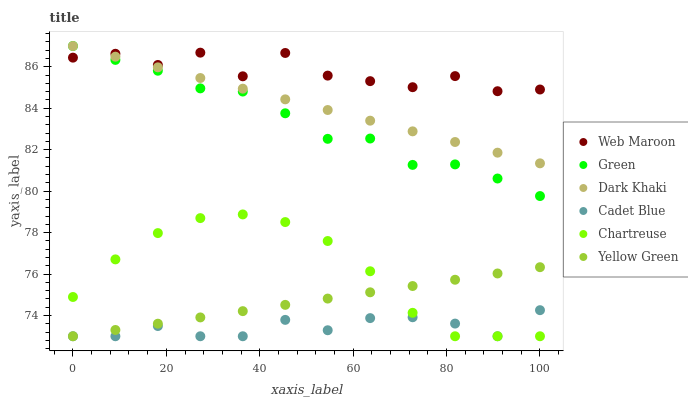Does Cadet Blue have the minimum area under the curve?
Answer yes or no. Yes. Does Web Maroon have the maximum area under the curve?
Answer yes or no. Yes. Does Yellow Green have the minimum area under the curve?
Answer yes or no. No. Does Yellow Green have the maximum area under the curve?
Answer yes or no. No. Is Yellow Green the smoothest?
Answer yes or no. Yes. Is Web Maroon the roughest?
Answer yes or no. Yes. Is Web Maroon the smoothest?
Answer yes or no. No. Is Yellow Green the roughest?
Answer yes or no. No. Does Cadet Blue have the lowest value?
Answer yes or no. Yes. Does Web Maroon have the lowest value?
Answer yes or no. No. Does Green have the highest value?
Answer yes or no. Yes. Does Yellow Green have the highest value?
Answer yes or no. No. Is Yellow Green less than Dark Khaki?
Answer yes or no. Yes. Is Green greater than Yellow Green?
Answer yes or no. Yes. Does Chartreuse intersect Cadet Blue?
Answer yes or no. Yes. Is Chartreuse less than Cadet Blue?
Answer yes or no. No. Is Chartreuse greater than Cadet Blue?
Answer yes or no. No. Does Yellow Green intersect Dark Khaki?
Answer yes or no. No. 